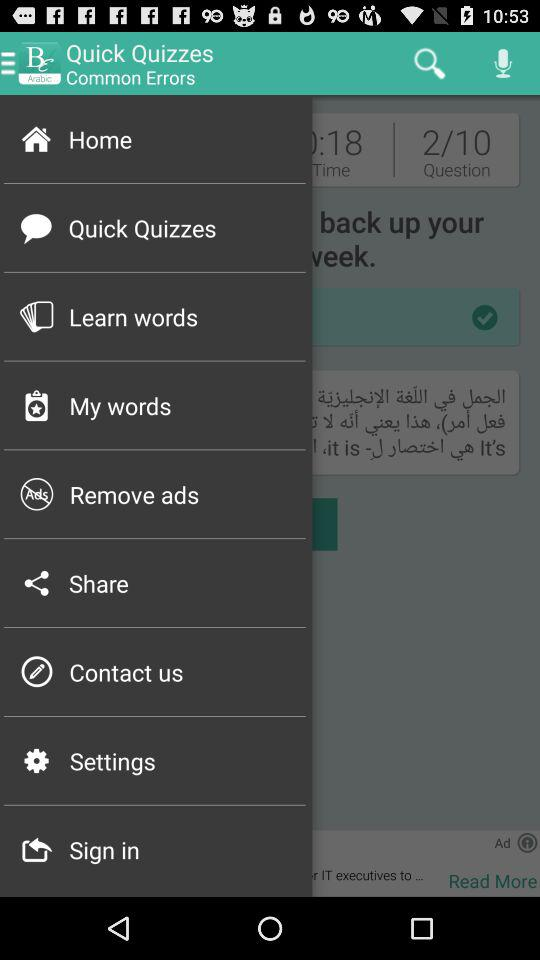How many questions in total are there? There are 10 questions in total. 